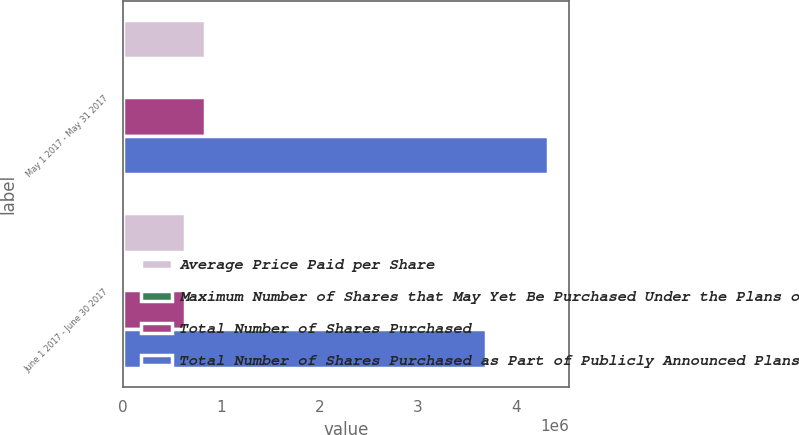Convert chart to OTSL. <chart><loc_0><loc_0><loc_500><loc_500><stacked_bar_chart><ecel><fcel>May 1 2017 - May 31 2017<fcel>June 1 2017 - June 30 2017<nl><fcel>Average Price Paid per Share<fcel>831250<fcel>631467<nl><fcel>Maximum Number of Shares that May Yet Be Purchased Under the Plans or Programs2<fcel>73.4<fcel>76.2<nl><fcel>Total Number of Shares Purchased<fcel>831250<fcel>631467<nl><fcel>Total Number of Shares Purchased as Part of Publicly Announced Plans or Programs2<fcel>4.3167e+06<fcel>3.68524e+06<nl></chart> 